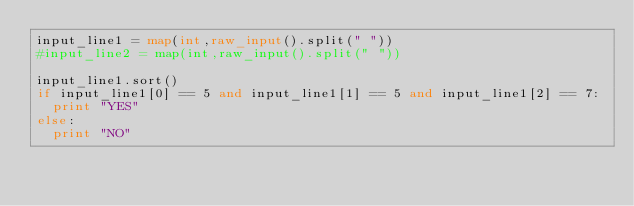Convert code to text. <code><loc_0><loc_0><loc_500><loc_500><_Python_>input_line1 = map(int,raw_input().split(" "))
#input_line2 = map(int,raw_input().split(" "))

input_line1.sort()
if input_line1[0] == 5 and input_line1[1] == 5 and input_line1[2] == 7:
	print "YES"
else:
	print "NO"</code> 